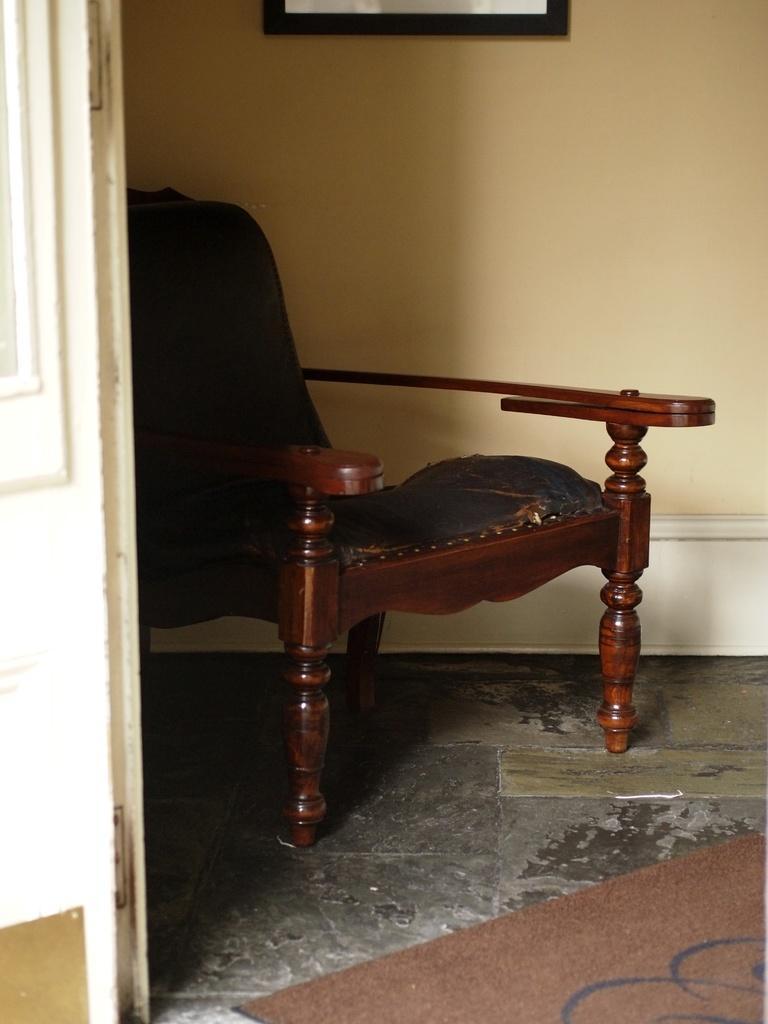In one or two sentences, can you explain what this image depicts? In this picture I can see there is a chair and it having a cushion on the chair and on the left there is a door and in the backdrop I can see there is a wall. 